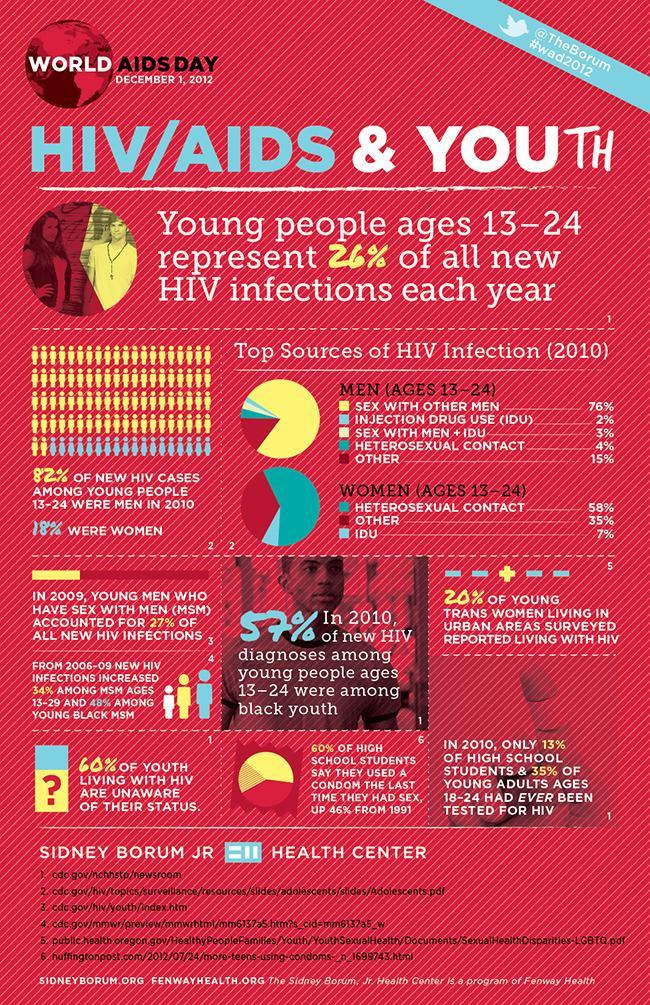What percentage of women in the age group of 13-24 had heterosexual contact as the source of HIV infection in 2010?
Answer the question with a short phrase. 58% What percentage of new HIV cases among young people 13-24 were women in 2010? 18% What percentage of high school students had ever been tested for HIV in 2010? 13% What percentage of new HIV cases among young people 13-24 were men in 2010? 82% What percentage of men in the age group of 13-24 had IDU as the source of HIV infection in 2010? 2% What is the top source of HIV infection (2010) in women in the age of 13-24? HETEROSEXUAL CONTACT What is the top source of HIV infection (2010) in men in the age of 13-24? SEX WITH OTHER MEN What percentage of youth living with HIV are unaware of their status in 2010? 60% What percentage of women in the age group of 13-24 had IDU as the source of HIV infection in 2010? 7% 